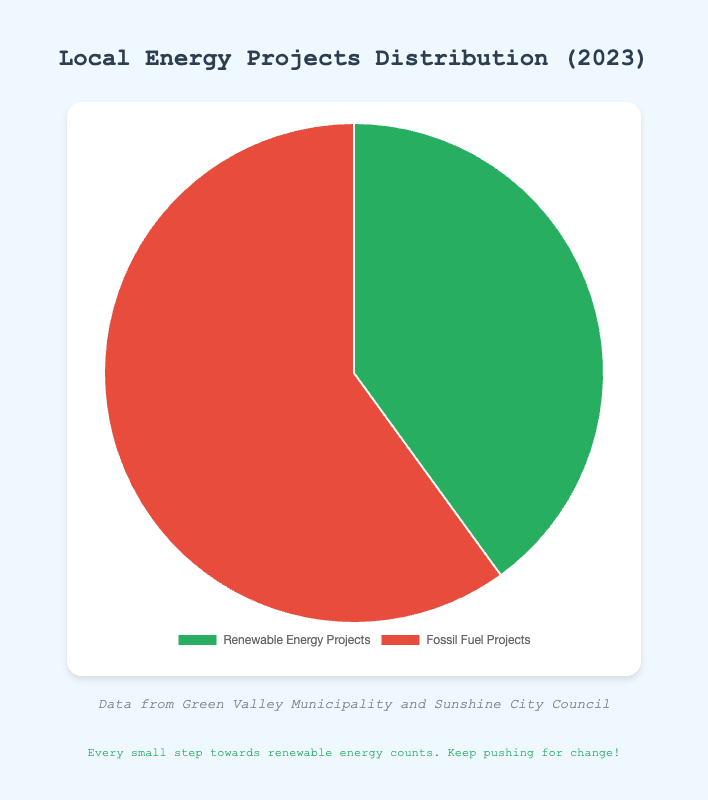What percentage of energy projects are renewable? The chart shows that renewable energy projects account for 40% of the total.
Answer: 40% What are the proportions of energy projects supported by local government? The chart depicts two segments: renewable energy projects at 40% and fossil fuel projects at 60%.
Answer: 40% for renewable energy and 60% for fossil fuel Which type of project is more heavily supported by local government? Fossil fuel projects are more heavily supported, as they make up 60% of the total projects.
Answer: Fossil fuel projects By what percentage do fossil fuel projects exceed renewable energy projects? Fossil fuel projects (60%) exceed renewable energy projects (40%) by 20%. This is calculated by subtracting 40% from 60%.
Answer: 20% If there were 100 energy projects, how many would be renewable? Given that 40% of the projects are renewable, out of 100 projects, 40% would be renewable. This is calculated as 100 * 0.40 = 40.
Answer: 40 projects How much more is the percentage of fossil fuel projects compared to renewable ones? Fossil fuel projects constitute 60% compared to 40% for renewable projects. The difference is 60% - 40% = 20%.
Answer: 20% Are there more than 50% fossil fuel projects? Yes, fossil fuel projects are 60%, which is greater than 50%.
Answer: Yes If the local government aimed to balance the proportion of renewable and fossil fuel projects evenly, by how much percentage would they need to increase renewable projects? To achieve 50% renewable projects, they need to increase from 40% to 50%. The required increase is 50% - 40% = 10%.
Answer: 10% What colors are used to represent renewable and fossil fuel projects? Renewable energy projects are represented by green, while fossil fuel projects are depicted in red.
Answer: Green for renewable, red for fossil fuel If the proportion of renewable projects increased to 50%, what would be the new proportion of fossil fuel projects? If renewable projects increased to 50%, the proportion of fossil fuel projects would decrease to 50% since the total must be 100%.
Answer: 50% 